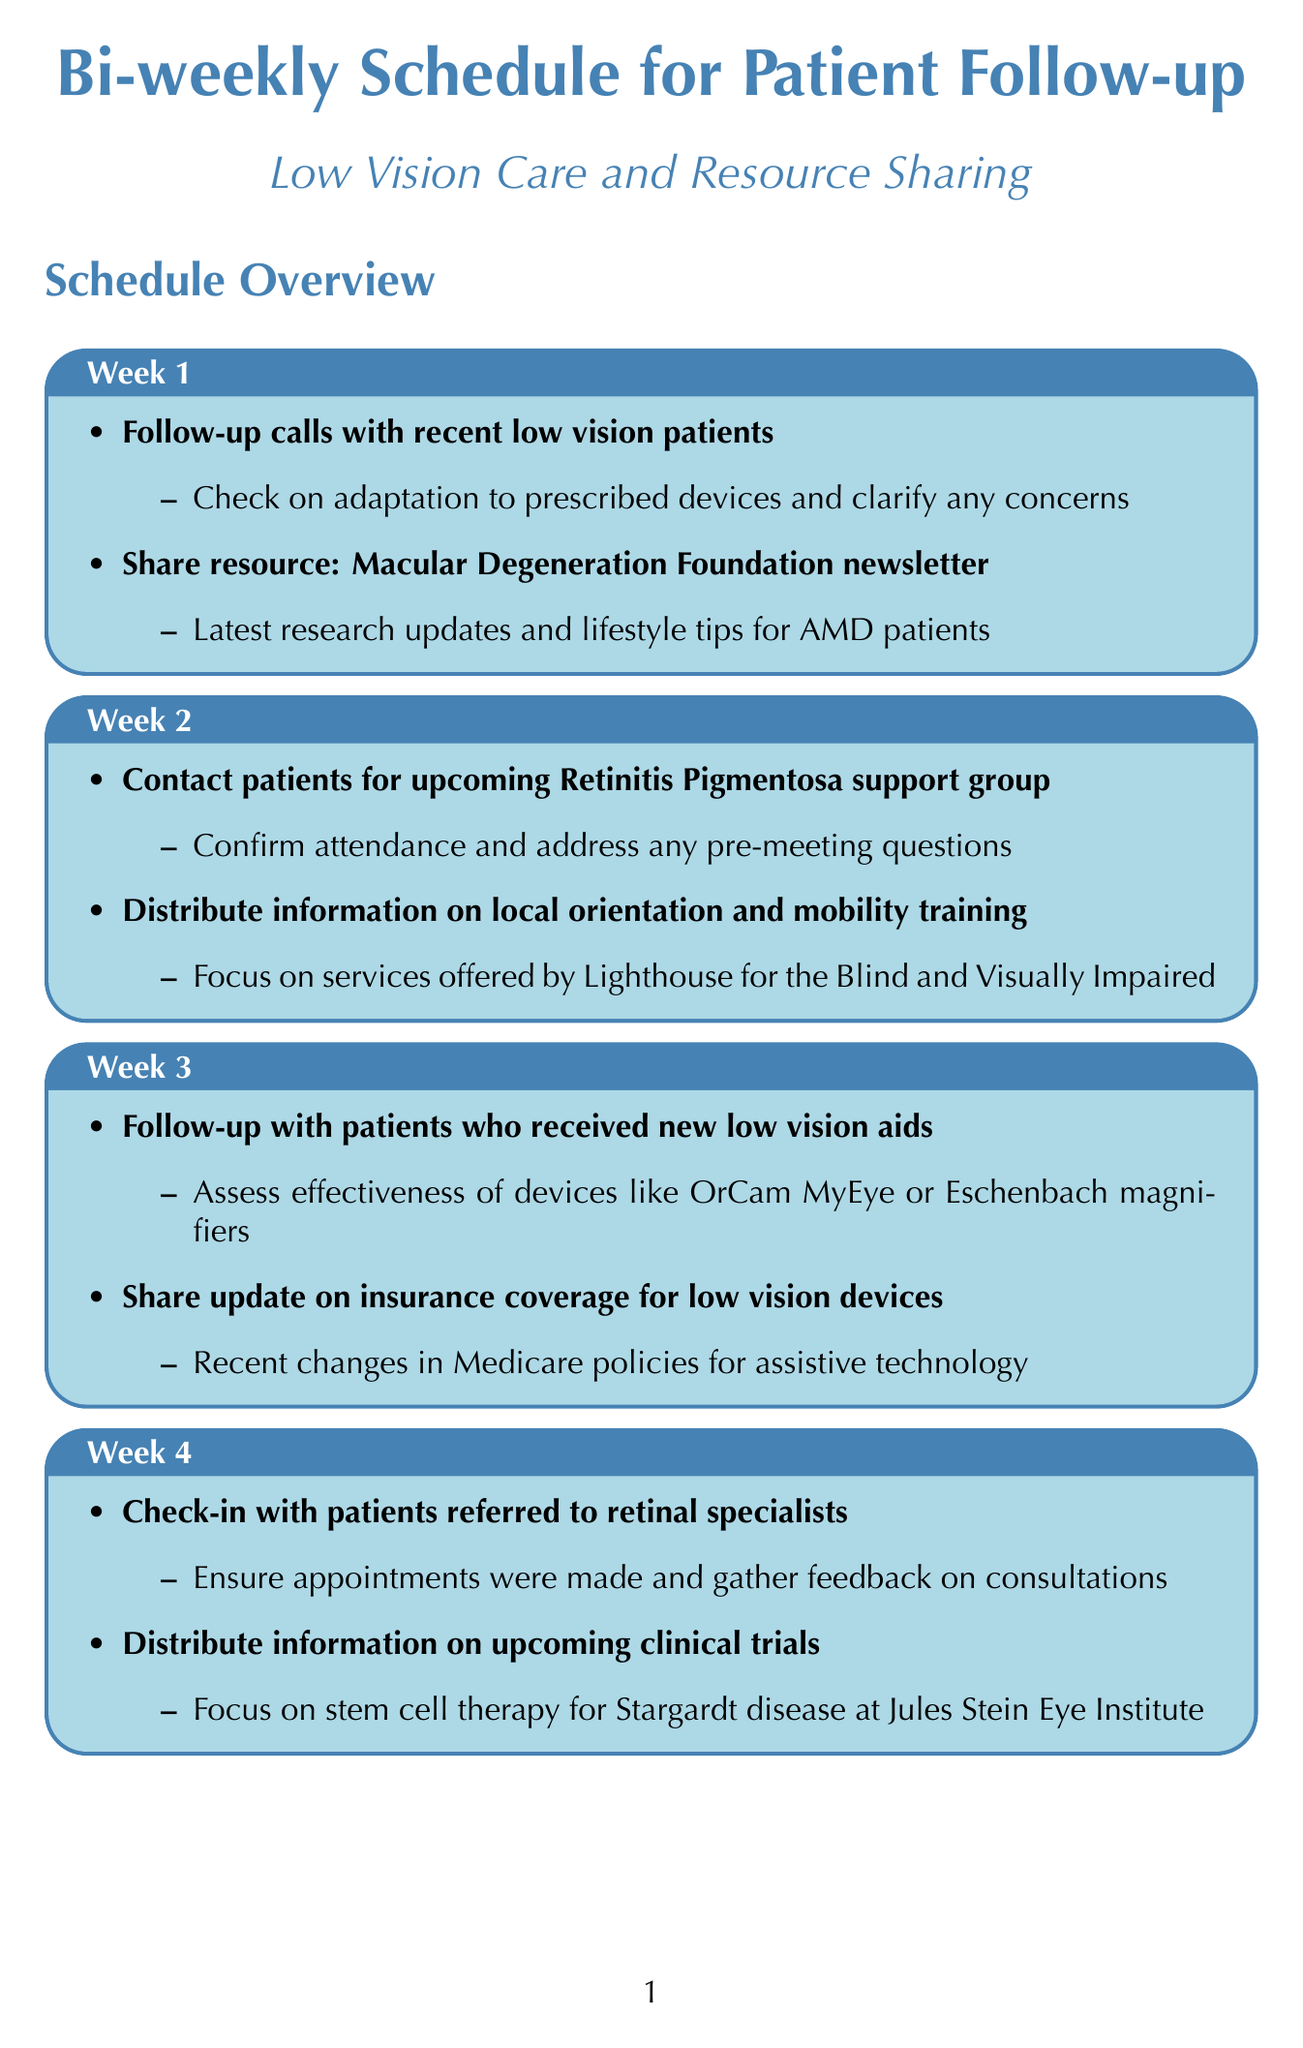What activities are scheduled for week 3? The activities scheduled for week 3 include follow-up with patients who received new low vision aids and sharing an update on insurance coverage for low vision devices.
Answer: Follow-up with patients who received new low vision aids, Share update on insurance coverage for low vision devices What is the focus of the resource shared in week 2? The focus of the resource shared in week 2 is on local orientation and mobility training programs.
Answer: Local orientation and mobility training programs How many weeks are covered in the schedule? The document outlines activities for 8 weeks.
Answer: 8 What is the task for week 6? The tasks for week 6 include contacting patients due for annual comprehensive low vision evaluation and distributing information on local support groups.
Answer: Contact patients due for annual comprehensive low vision evaluation, Distribute information on local support groups Which foundation's newsletter is shared in week 1? The newsletter shared in week 1 is from the Macular Degeneration Foundation.
Answer: Macular Degeneration Foundation In which week do patients check in regarding prescription eye drops? Patients check in regarding prescription eye drops in week 8.
Answer: Week 8 